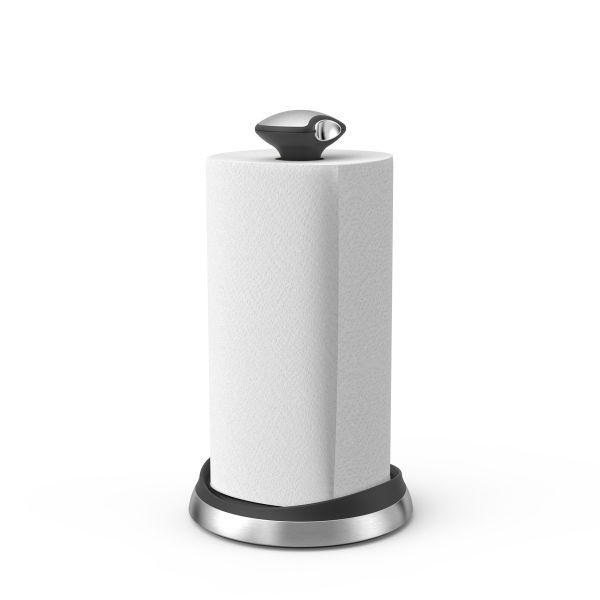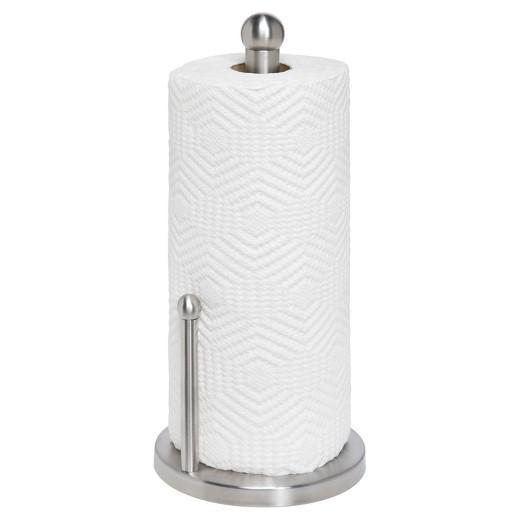The first image is the image on the left, the second image is the image on the right. Evaluate the accuracy of this statement regarding the images: "Only one of the paper towel rolls is on the paper towel holder.". Is it true? Answer yes or no. No. The first image is the image on the left, the second image is the image on the right. For the images displayed, is the sentence "One image shows a towel roll without a stand and without any sheet unfurled." factually correct? Answer yes or no. No. 